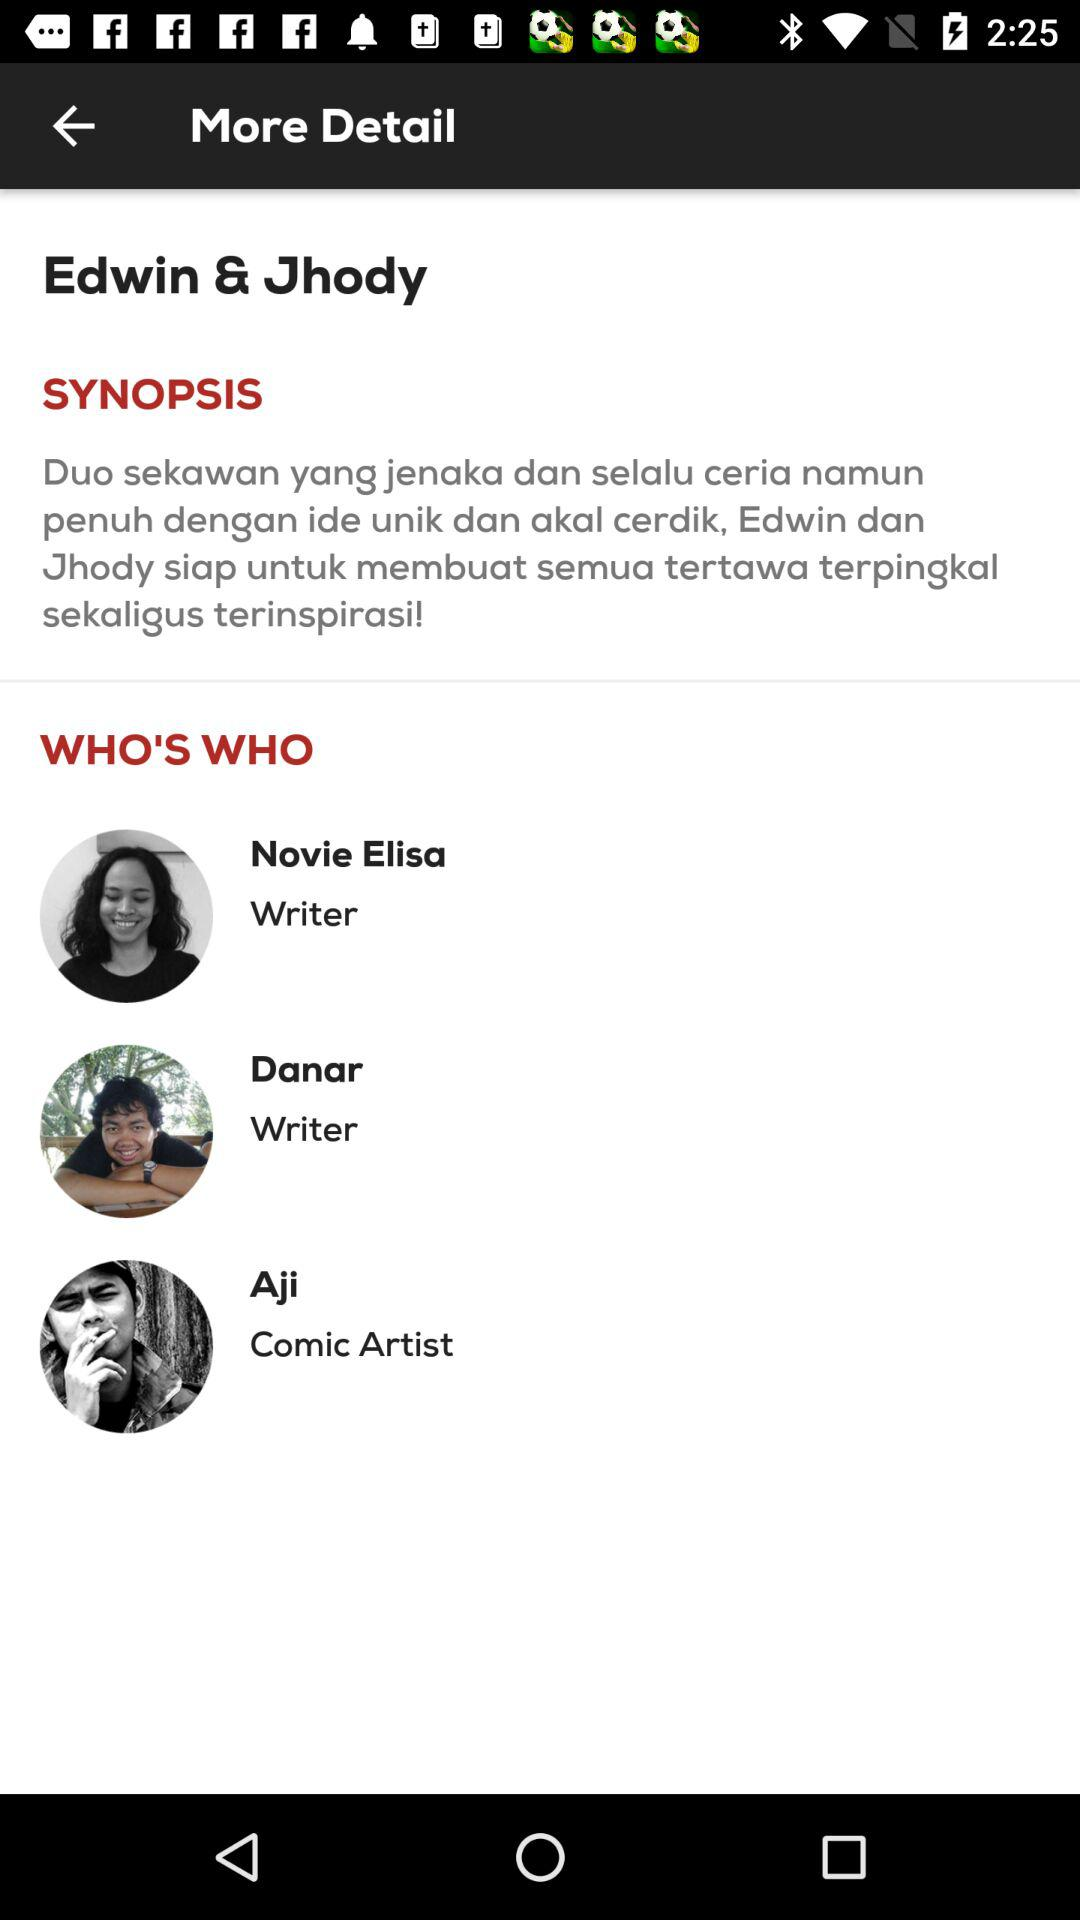Who is the comic artist? The comic artist is Aji. 